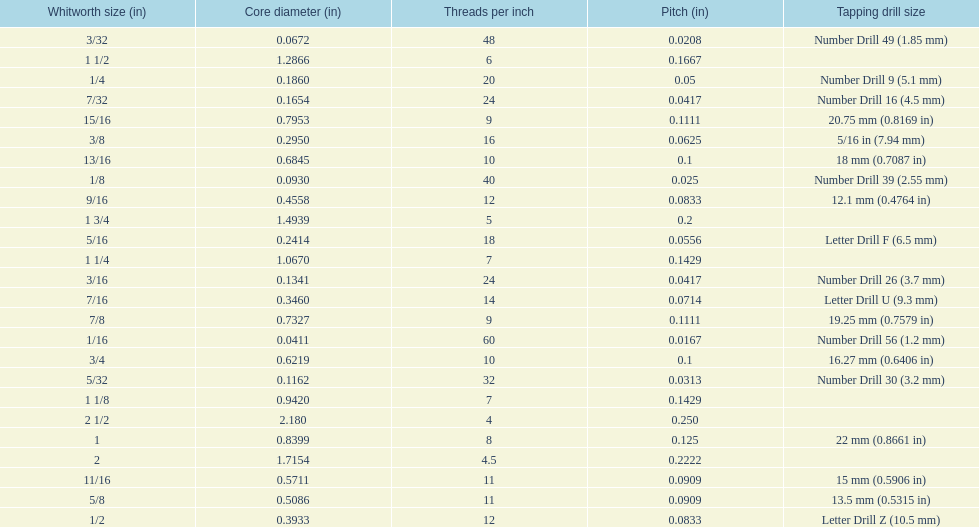Parse the table in full. {'header': ['Whitworth size (in)', 'Core diameter (in)', 'Threads per\xa0inch', 'Pitch (in)', 'Tapping drill size'], 'rows': [['3/32', '0.0672', '48', '0.0208', 'Number Drill 49 (1.85\xa0mm)'], ['1 1/2', '1.2866', '6', '0.1667', ''], ['1/4', '0.1860', '20', '0.05', 'Number Drill 9 (5.1\xa0mm)'], ['7/32', '0.1654', '24', '0.0417', 'Number Drill 16 (4.5\xa0mm)'], ['15/16', '0.7953', '9', '0.1111', '20.75\xa0mm (0.8169\xa0in)'], ['3/8', '0.2950', '16', '0.0625', '5/16\xa0in (7.94\xa0mm)'], ['13/16', '0.6845', '10', '0.1', '18\xa0mm (0.7087\xa0in)'], ['1/8', '0.0930', '40', '0.025', 'Number Drill 39 (2.55\xa0mm)'], ['9/16', '0.4558', '12', '0.0833', '12.1\xa0mm (0.4764\xa0in)'], ['1 3/4', '1.4939', '5', '0.2', ''], ['5/16', '0.2414', '18', '0.0556', 'Letter Drill F (6.5\xa0mm)'], ['1 1/4', '1.0670', '7', '0.1429', ''], ['3/16', '0.1341', '24', '0.0417', 'Number Drill 26 (3.7\xa0mm)'], ['7/16', '0.3460', '14', '0.0714', 'Letter Drill U (9.3\xa0mm)'], ['7/8', '0.7327', '9', '0.1111', '19.25\xa0mm (0.7579\xa0in)'], ['1/16', '0.0411', '60', '0.0167', 'Number Drill 56 (1.2\xa0mm)'], ['3/4', '0.6219', '10', '0.1', '16.27\xa0mm (0.6406\xa0in)'], ['5/32', '0.1162', '32', '0.0313', 'Number Drill 30 (3.2\xa0mm)'], ['1 1/8', '0.9420', '7', '0.1429', ''], ['2 1/2', '2.180', '4', '0.250', ''], ['1', '0.8399', '8', '0.125', '22\xa0mm (0.8661\xa0in)'], ['2', '1.7154', '4.5', '0.2222', ''], ['11/16', '0.5711', '11', '0.0909', '15\xa0mm (0.5906\xa0in)'], ['5/8', '0.5086', '11', '0.0909', '13.5\xa0mm (0.5315\xa0in)'], ['1/2', '0.3933', '12', '0.0833', 'Letter Drill Z (10.5\xa0mm)']]} How many threads per inch does a 9/16 have? 12. 